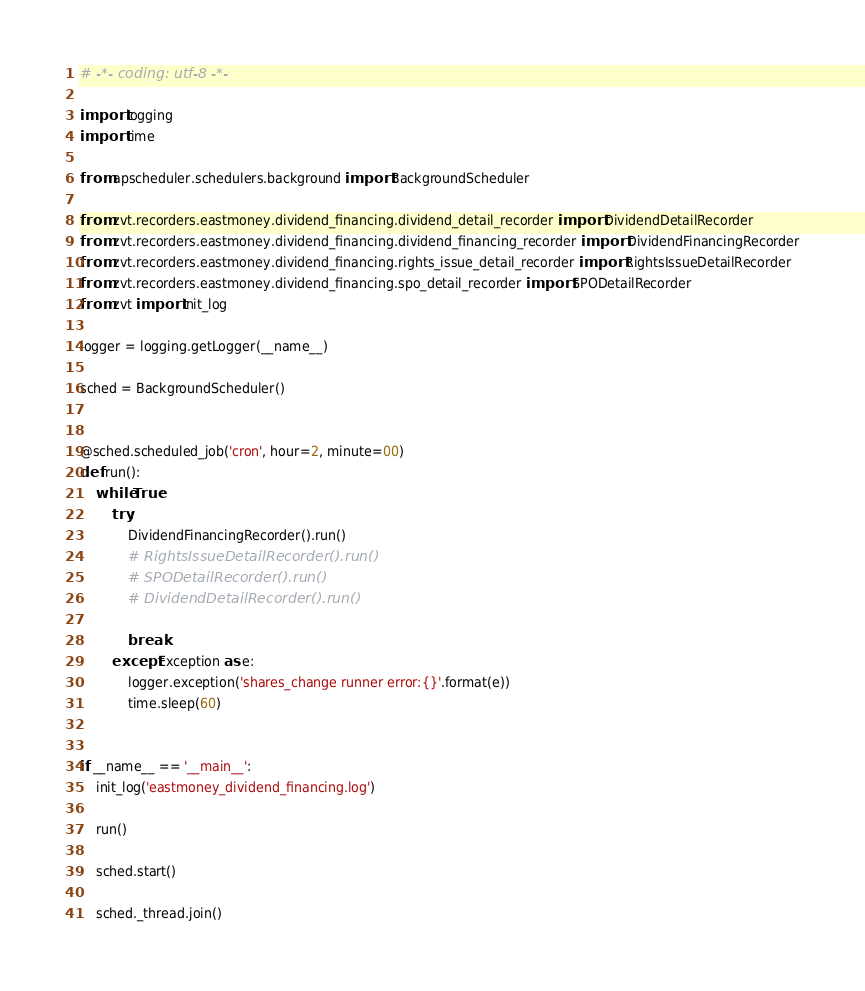<code> <loc_0><loc_0><loc_500><loc_500><_Python_># -*- coding: utf-8 -*-

import logging
import time

from apscheduler.schedulers.background import BackgroundScheduler

from zvt.recorders.eastmoney.dividend_financing.dividend_detail_recorder import DividendDetailRecorder
from zvt.recorders.eastmoney.dividend_financing.dividend_financing_recorder import DividendFinancingRecorder
from zvt.recorders.eastmoney.dividend_financing.rights_issue_detail_recorder import RightsIssueDetailRecorder
from zvt.recorders.eastmoney.dividend_financing.spo_detail_recorder import SPODetailRecorder
from zvt import init_log

logger = logging.getLogger(__name__)

sched = BackgroundScheduler()


@sched.scheduled_job('cron', hour=2, minute=00)
def run():
    while True:
        try:
            DividendFinancingRecorder().run()
            # RightsIssueDetailRecorder().run()
            # SPODetailRecorder().run()
            # DividendDetailRecorder().run()

            break
        except Exception as e:
            logger.exception('shares_change runner error:{}'.format(e))
            time.sleep(60)


if __name__ == '__main__':
    init_log('eastmoney_dividend_financing.log')

    run()

    sched.start()

    sched._thread.join()
</code> 